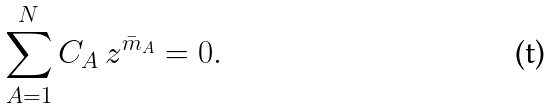<formula> <loc_0><loc_0><loc_500><loc_500>\sum _ { A = 1 } ^ { N } C _ { A } \, z ^ { \bar { m } _ { A } } = 0 .</formula> 